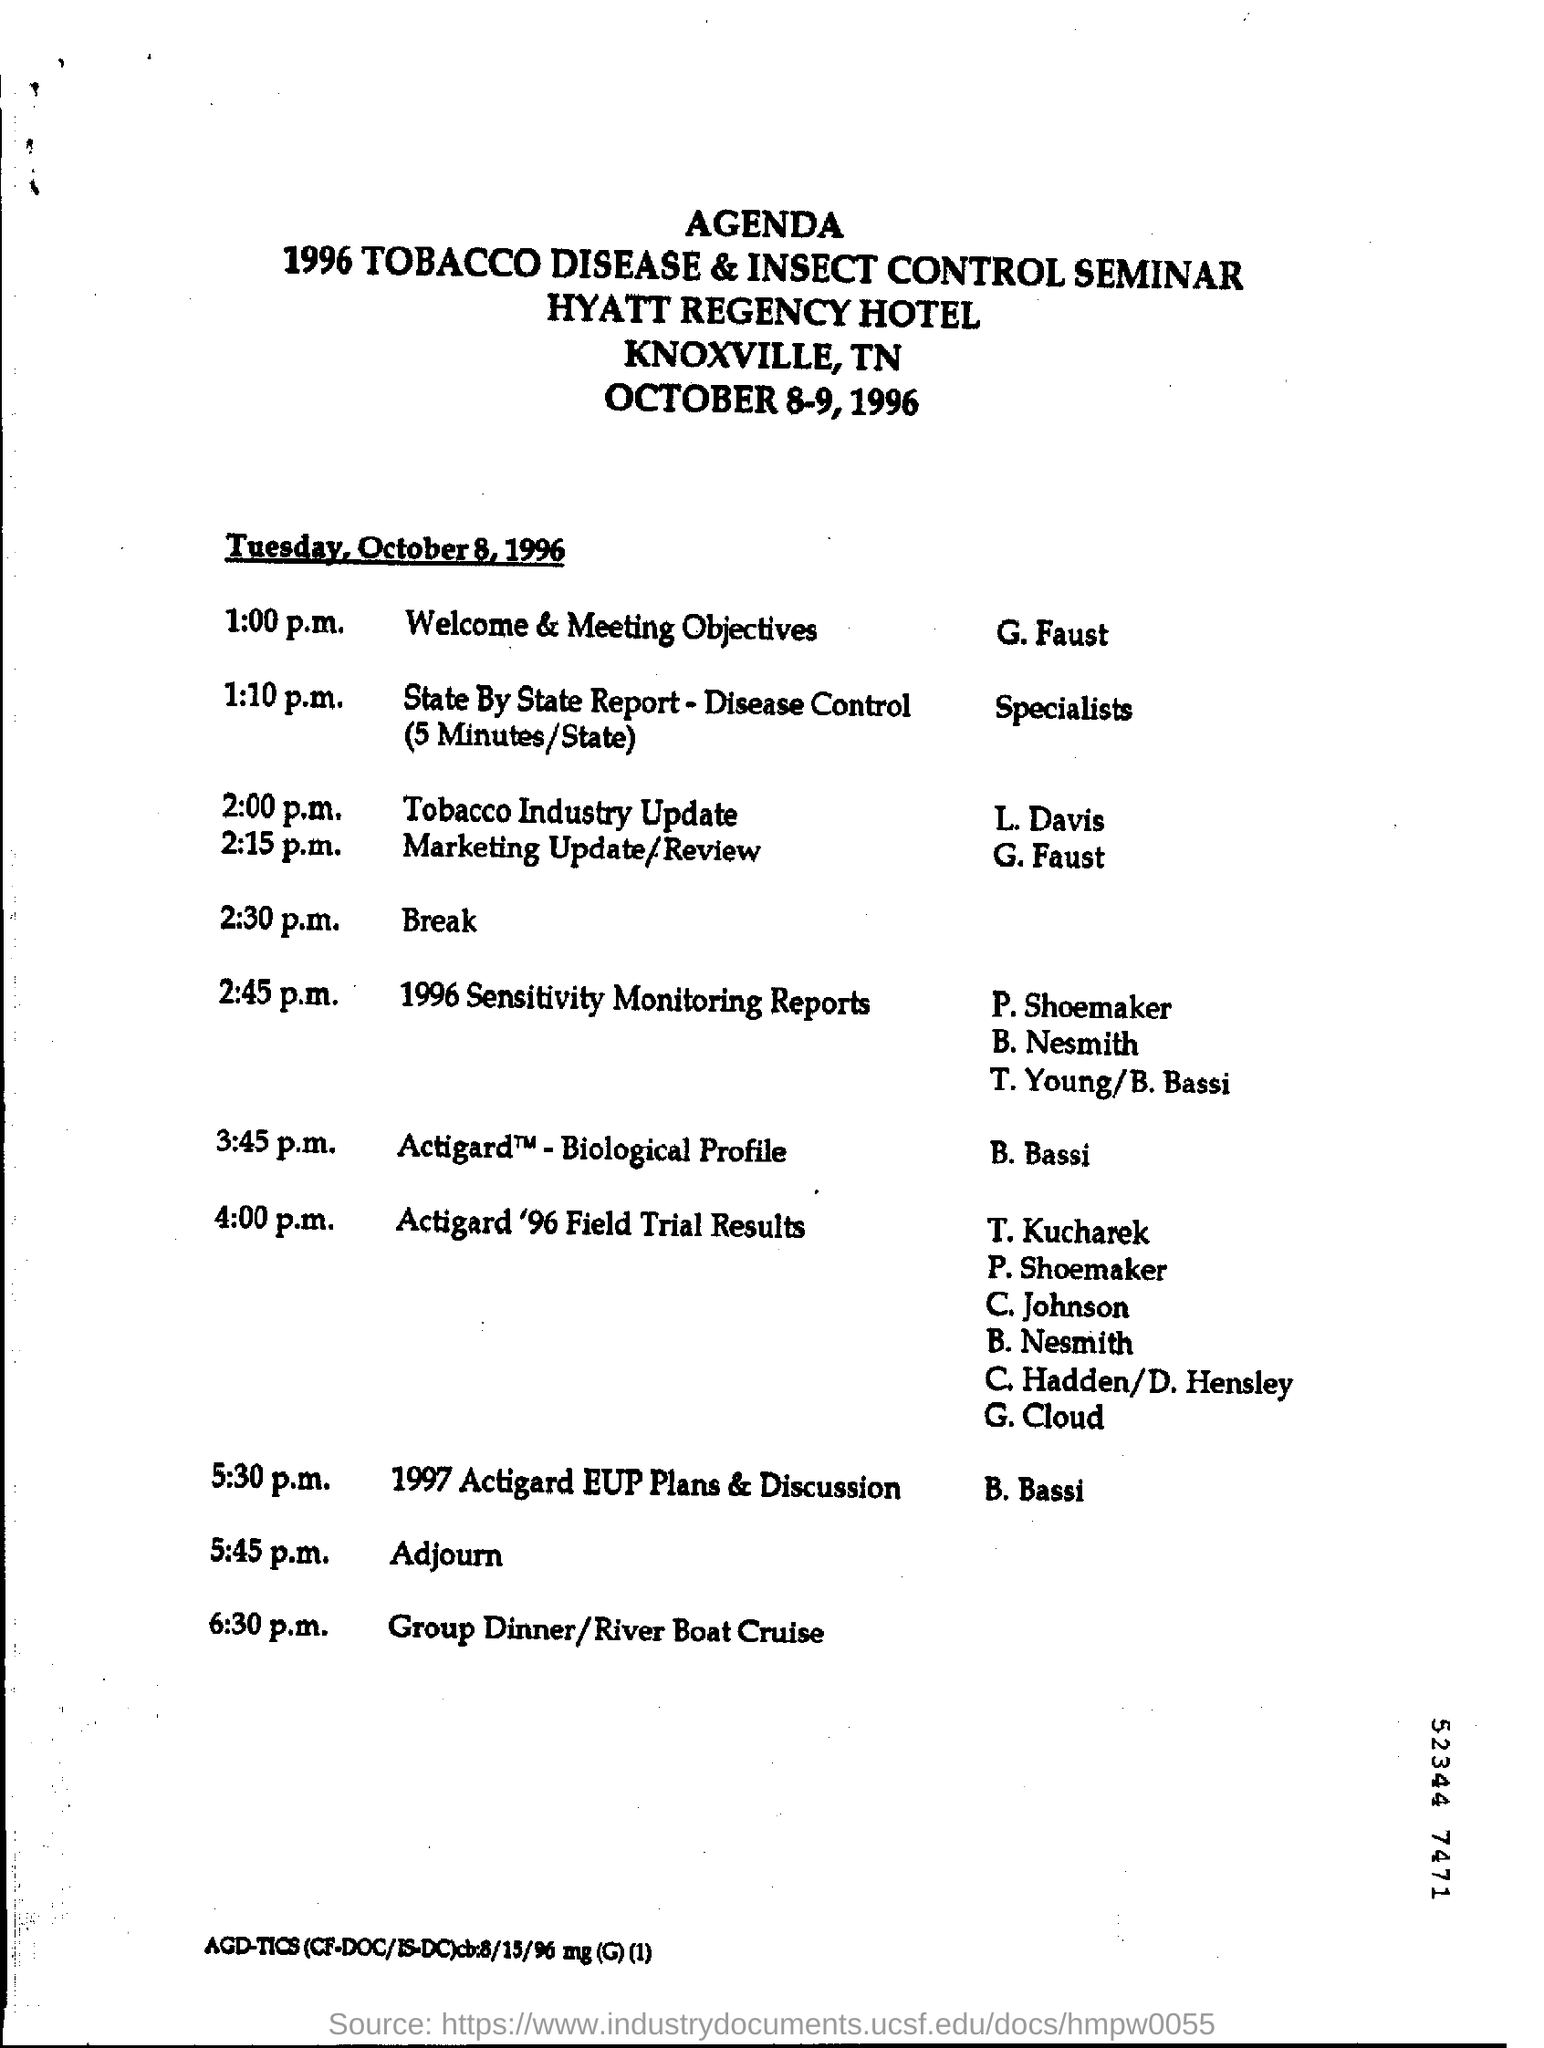What is the name of the seminar?
Give a very brief answer. 1996 Tobacco Disease & Insect Control. 